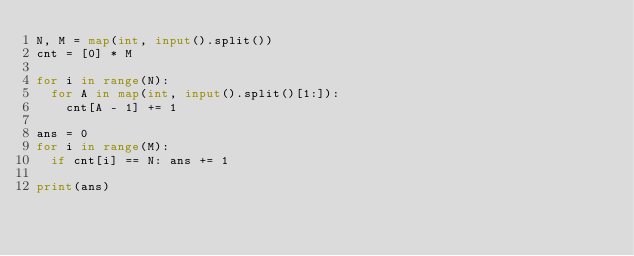Convert code to text. <code><loc_0><loc_0><loc_500><loc_500><_Python_>N, M = map(int, input().split())
cnt = [0] * M

for i in range(N):
	for A in map(int, input().split()[1:]):
		cnt[A - 1] += 1

ans = 0
for i in range(M):
	if cnt[i] == N: ans += 1

print(ans)
</code> 